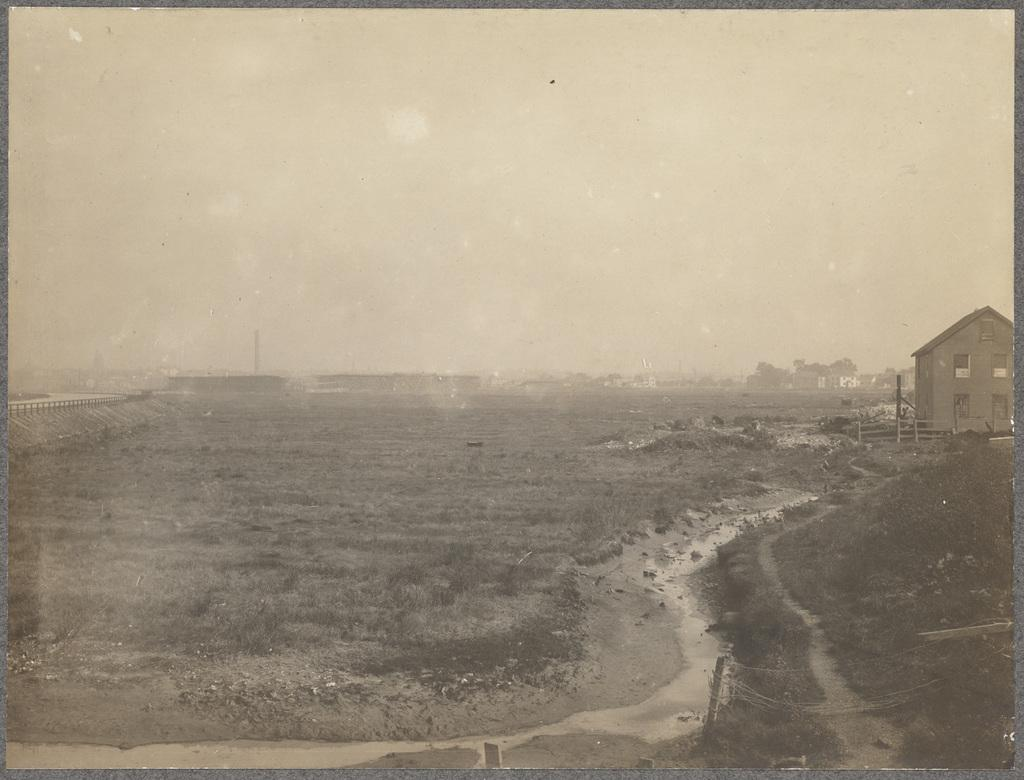What structure is located on the right side of the image? There is a house on the right side of the image. What type of landscape is in the center of the image? There is grassland in the center of the image. What can be seen in the background of the image? There are buildings in the background of the image. What type of health care facility can be seen in the image? There is no health care facility present in the image; it features a house, grassland, and buildings in the background. What type of leather goods are visible in the image? There are no leather goods present in the image. 